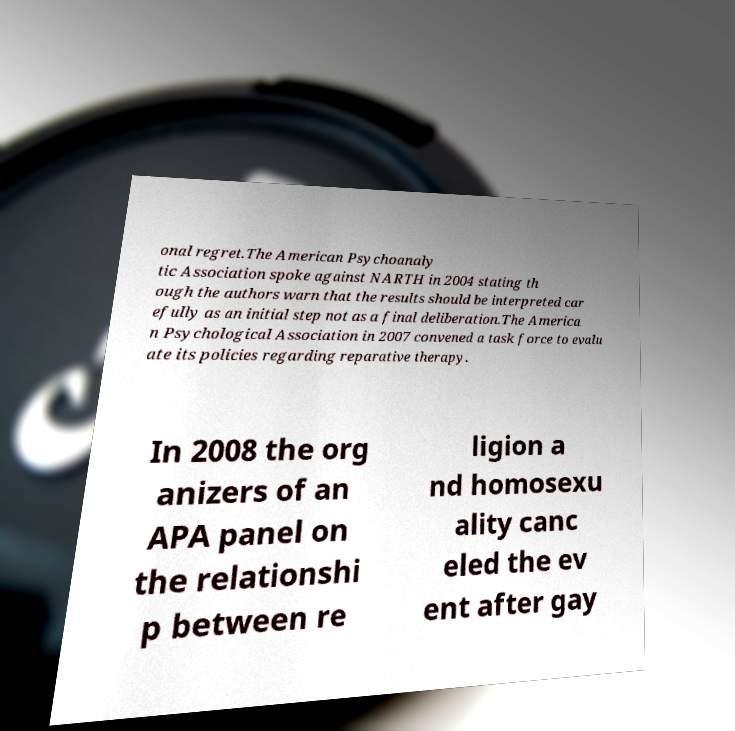Can you read and provide the text displayed in the image?This photo seems to have some interesting text. Can you extract and type it out for me? onal regret.The American Psychoanaly tic Association spoke against NARTH in 2004 stating th ough the authors warn that the results should be interpreted car efully as an initial step not as a final deliberation.The America n Psychological Association in 2007 convened a task force to evalu ate its policies regarding reparative therapy. In 2008 the org anizers of an APA panel on the relationshi p between re ligion a nd homosexu ality canc eled the ev ent after gay 